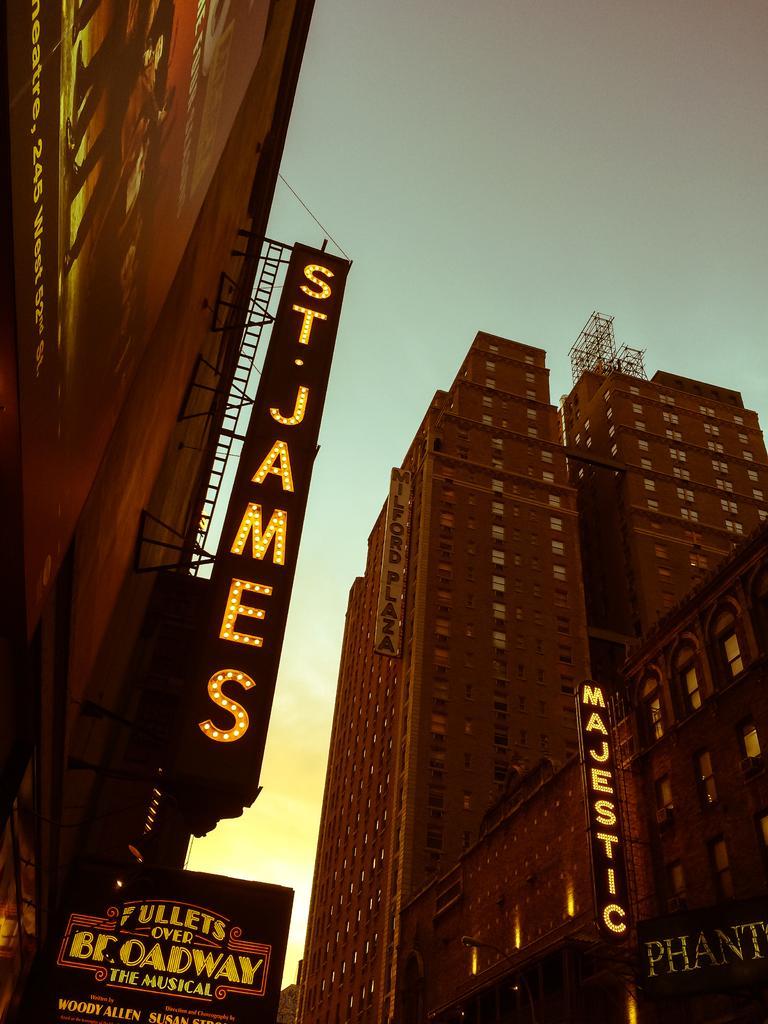Can you describe this image briefly? In this image we can see buildings, truss, banners, lights and other objects. In the background of the image there is the sky. 